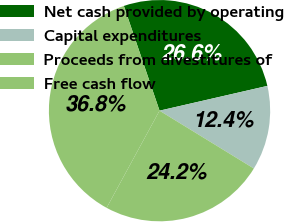Convert chart. <chart><loc_0><loc_0><loc_500><loc_500><pie_chart><fcel>Net cash provided by operating<fcel>Capital expenditures<fcel>Proceeds from divestitures of<fcel>Free cash flow<nl><fcel>26.63%<fcel>12.35%<fcel>24.18%<fcel>36.84%<nl></chart> 